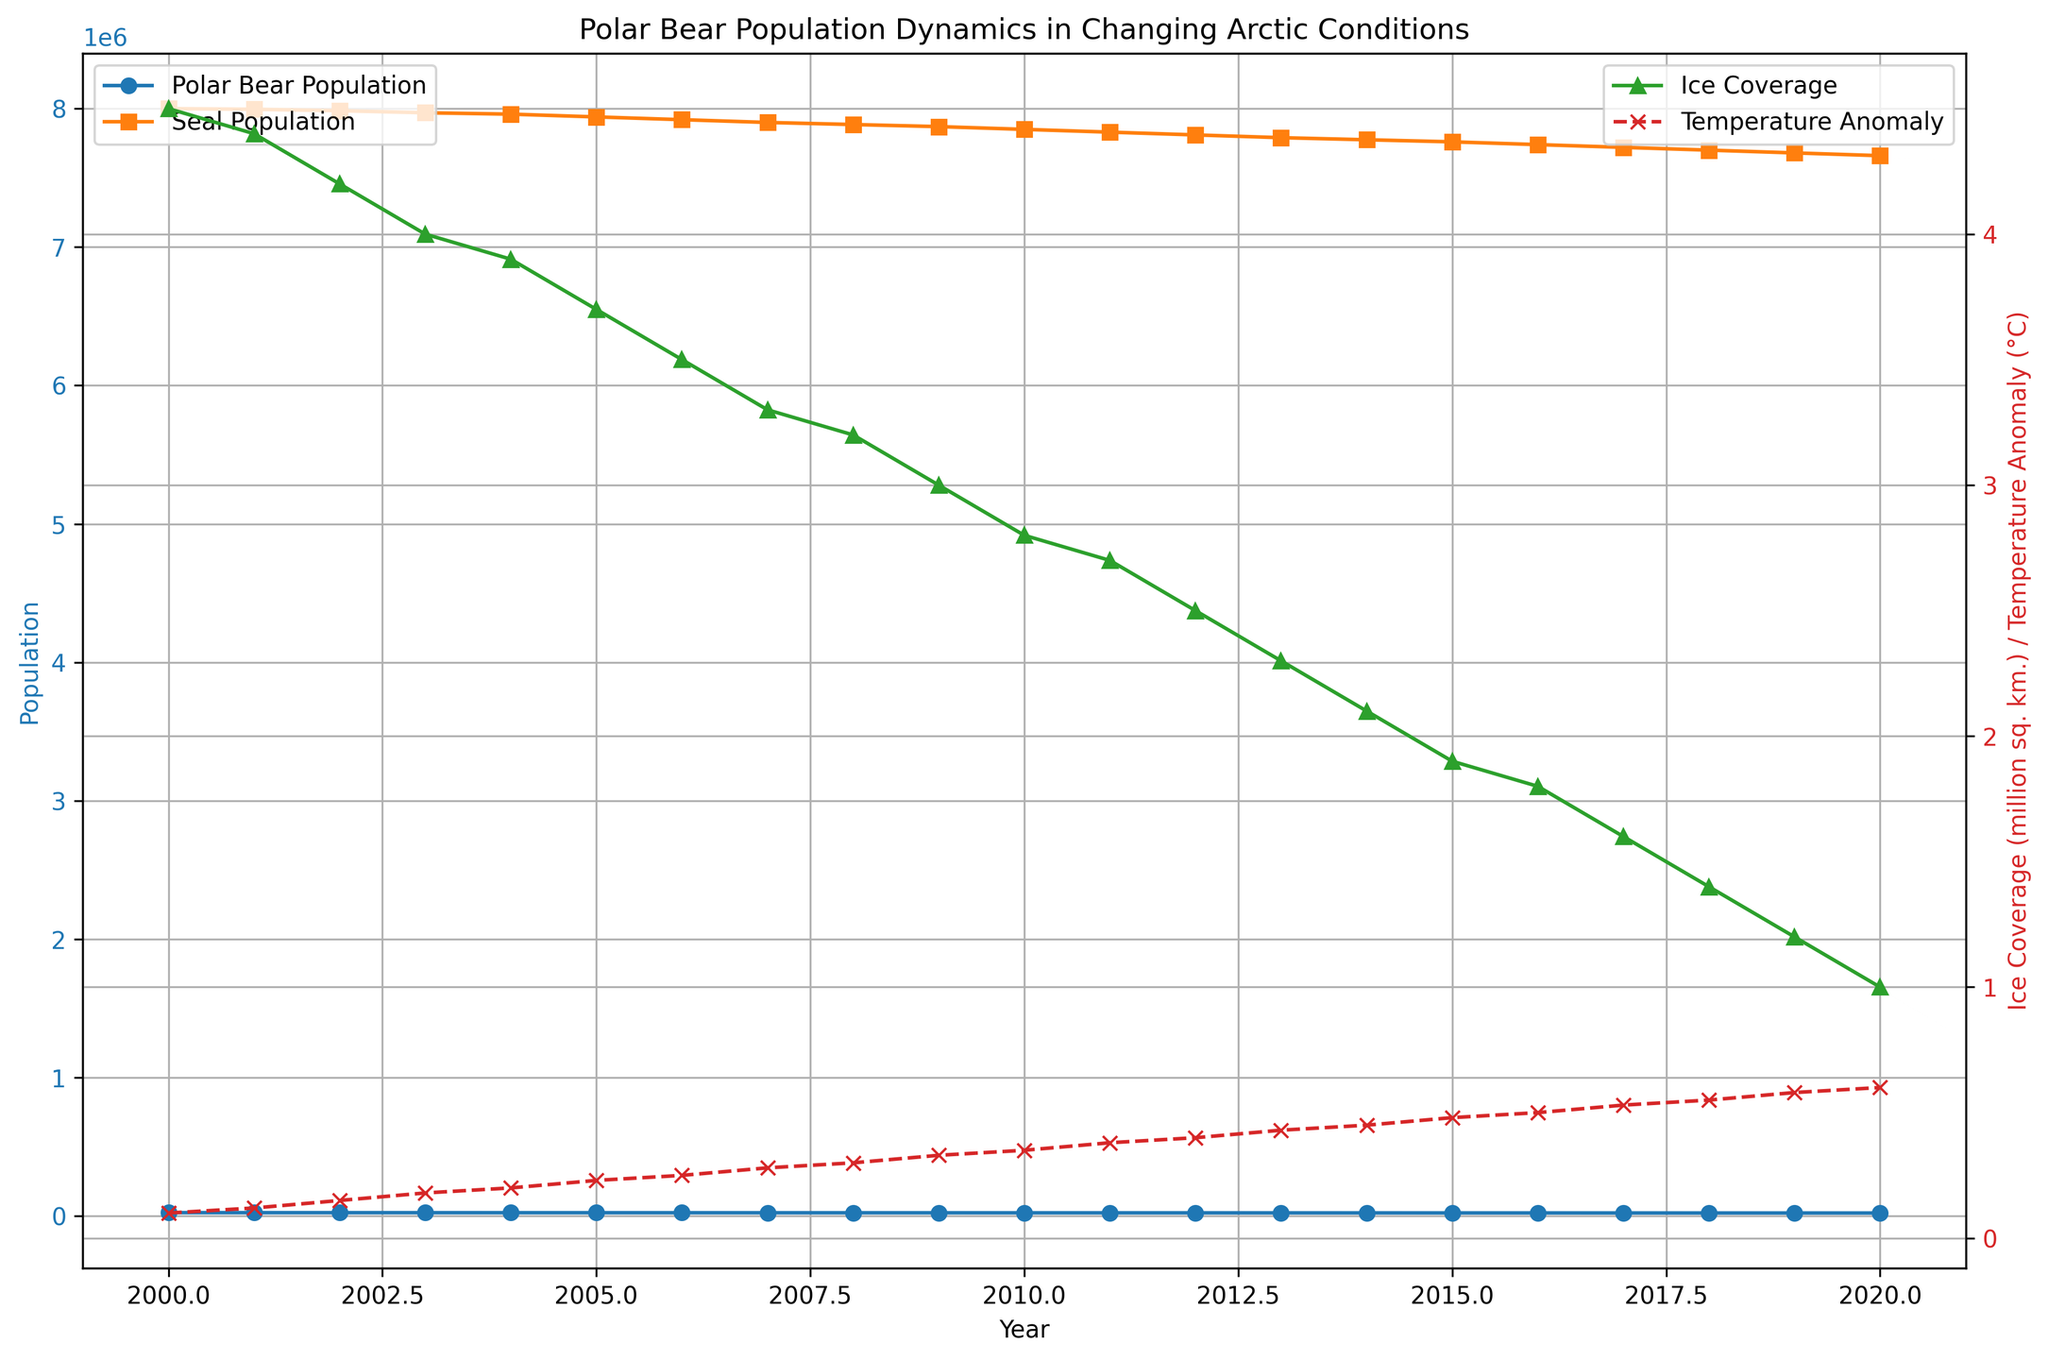What trend do you observe in the polar bear population over the years? By looking at the blue line with circular markers, we see that the polar bear population decreases gradually from 25000 in 2000 to 22300 in 2020.
Answer: Decreasing How does the seal population compare to the polar bear population in 2010? By looking at the data points for the year 2010, the blue line shows the polar bear population is 23700, while the orange line with square markers shows the seal population is 7850000.
Answer: Seal population is much higher What is the temperature anomaly in the year with the lowest ice coverage? By finding the minimum point on the green line with triangle markers, we see the lowest ice coverage occurs in 2020 at 1.0 million sq. km. The corresponding temperature anomaly from the red dashed line with x markers is 0.6°C.
Answer: 0.6°C Which year shows the greatest difference between seal population and polar bear population? To find the maximum difference, calculate the difference for each year: (SealPopulation - PolarBearPopulation). The visual inspection suggests starting with 2000 where the seal population is 8000000 and polar bear is 25000, giving a difference of 7975000, which appears to be the maximum.
Answer: 2000 What pattern is evident between ice coverage and the temperature anomaly? The data shows an inverse relationship, as the green line decreases (ice coverage drops), the red line increases (temperature anomaly rises). This pattern suggests that as temperature anomaly increases, ice coverage decreases.
Answer: Inverse relationship In which year did the polar bear population first drop below 24000? By following the blue line closely, we see that the polar bear population first drops below 24000 in 2009.
Answer: 2009 Between 2010 and 2015, how many years saw a decrease in ice coverage? From the green line, check each year from 2010 (2.8) to 2015 (1.9). The values in between are 2.7, 2.5, 2.3, and 2.1, all showing a decrease each consecutive year. Thus, all 5 years saw a decrease.
Answer: 5 years How does the rate of decrease in ice coverage compare before and after 2010? Compare the slope of the green line before 2010 and after 2010. Before 2010, ice coverage drops from 4.5 to 2.8 (a decrease of 1.7), over 10 years. After 2010, ice coverage drops from 2.8 to 1.0 (a decrease of 1.8), over 10 years. The rates are comparable; however, the second decade shows a marginally faster decline.
Answer: Slightly faster decline after 2010 